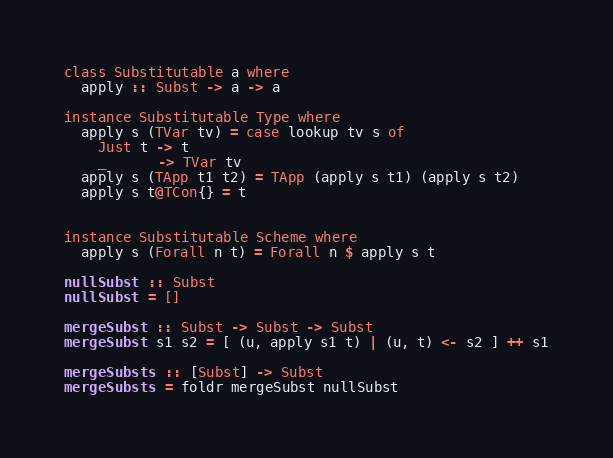<code> <loc_0><loc_0><loc_500><loc_500><_Haskell_>
class Substitutable a where
  apply :: Subst -> a -> a

instance Substitutable Type where
  apply s (TVar tv) = case lookup tv s of
    Just t -> t
    _      -> TVar tv
  apply s (TApp t1 t2) = TApp (apply s t1) (apply s t2)
  apply s t@TCon{} = t


instance Substitutable Scheme where
  apply s (Forall n t) = Forall n $ apply s t

nullSubst :: Subst
nullSubst = []

mergeSubst :: Subst -> Subst -> Subst
mergeSubst s1 s2 = [ (u, apply s1 t) | (u, t) <- s2 ] ++ s1

mergeSubsts :: [Subst] -> Subst
mergeSubsts = foldr mergeSubst nullSubst
</code> 